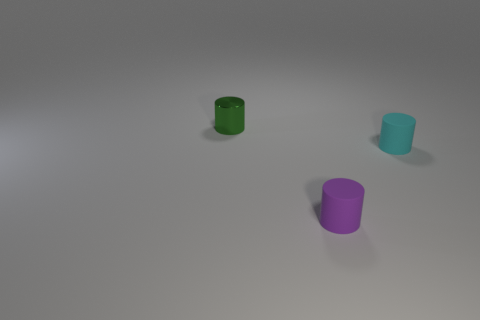How many other things are there of the same material as the tiny green object?
Your answer should be very brief. 0. What number of cyan objects are either small cylinders or shiny things?
Offer a terse response. 1. There is a tiny green metal object to the left of the small purple rubber cylinder; is it the same shape as the small thing that is to the right of the purple matte cylinder?
Your answer should be compact. Yes. How many objects are either purple rubber things or things in front of the green cylinder?
Provide a succinct answer. 2. There is a cylinder that is both behind the purple rubber object and left of the small cyan matte thing; what is its material?
Provide a short and direct response. Metal. There is a cylinder that is in front of the small cyan matte thing; what is it made of?
Your answer should be compact. Rubber. There is another thing that is the same material as the purple object; what is its color?
Your response must be concise. Cyan. Do the tiny cyan thing and the tiny object to the left of the purple matte object have the same shape?
Offer a very short reply. Yes. There is a metal object; are there any small cyan rubber objects right of it?
Make the answer very short. Yes. Is the size of the cyan rubber thing the same as the cylinder behind the cyan rubber cylinder?
Provide a short and direct response. Yes. 